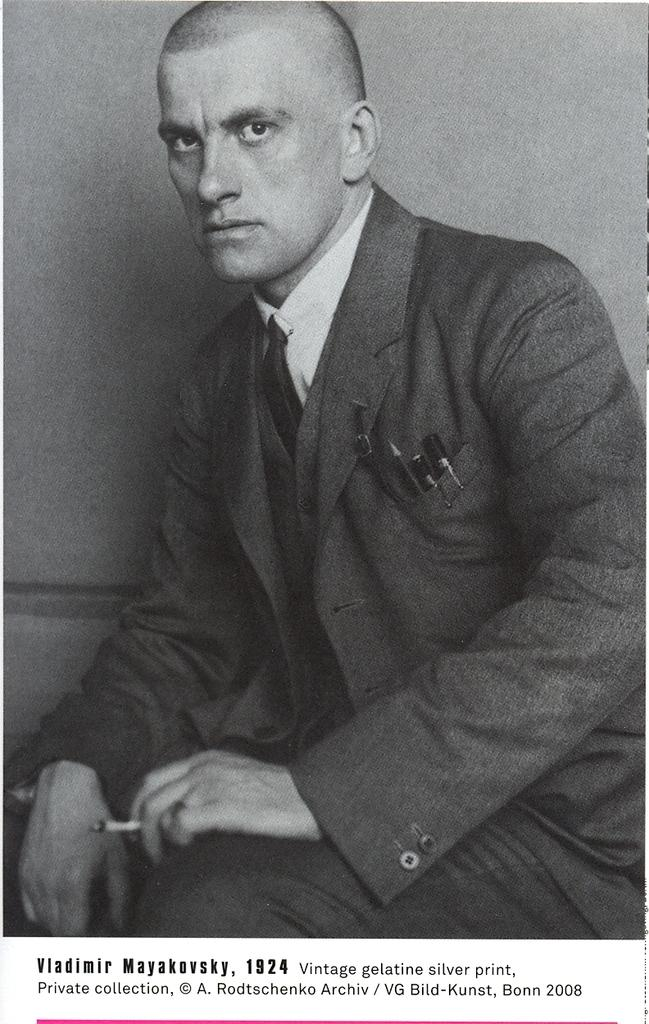What is the color scheme of the image? The image is black and white. What can be seen in the background of the image? There is a wall in the background of the image. How many donkeys are visible in the image? There are no donkeys present in the image. What type of metal is the babies' crib made of in the image? There are no babies or cribs present in the image. 